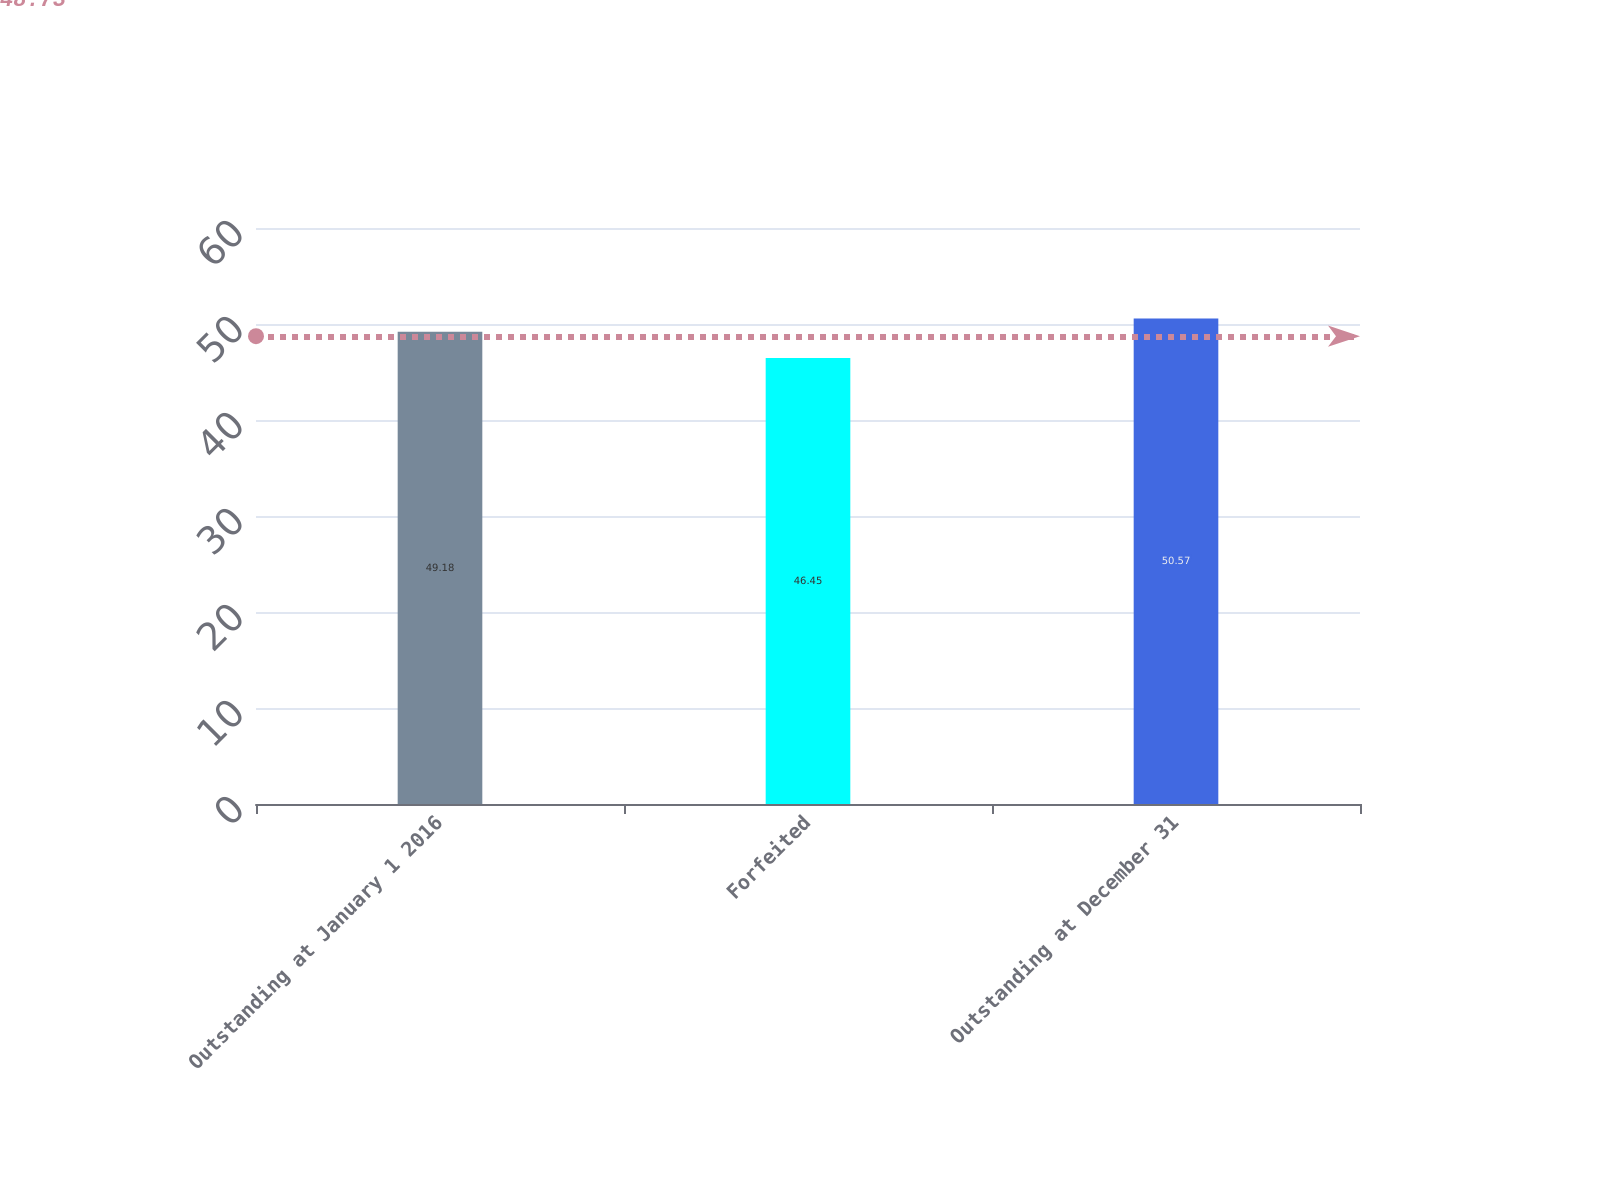<chart> <loc_0><loc_0><loc_500><loc_500><bar_chart><fcel>Outstanding at January 1 2016<fcel>Forfeited<fcel>Outstanding at December 31<nl><fcel>49.18<fcel>46.45<fcel>50.57<nl></chart> 